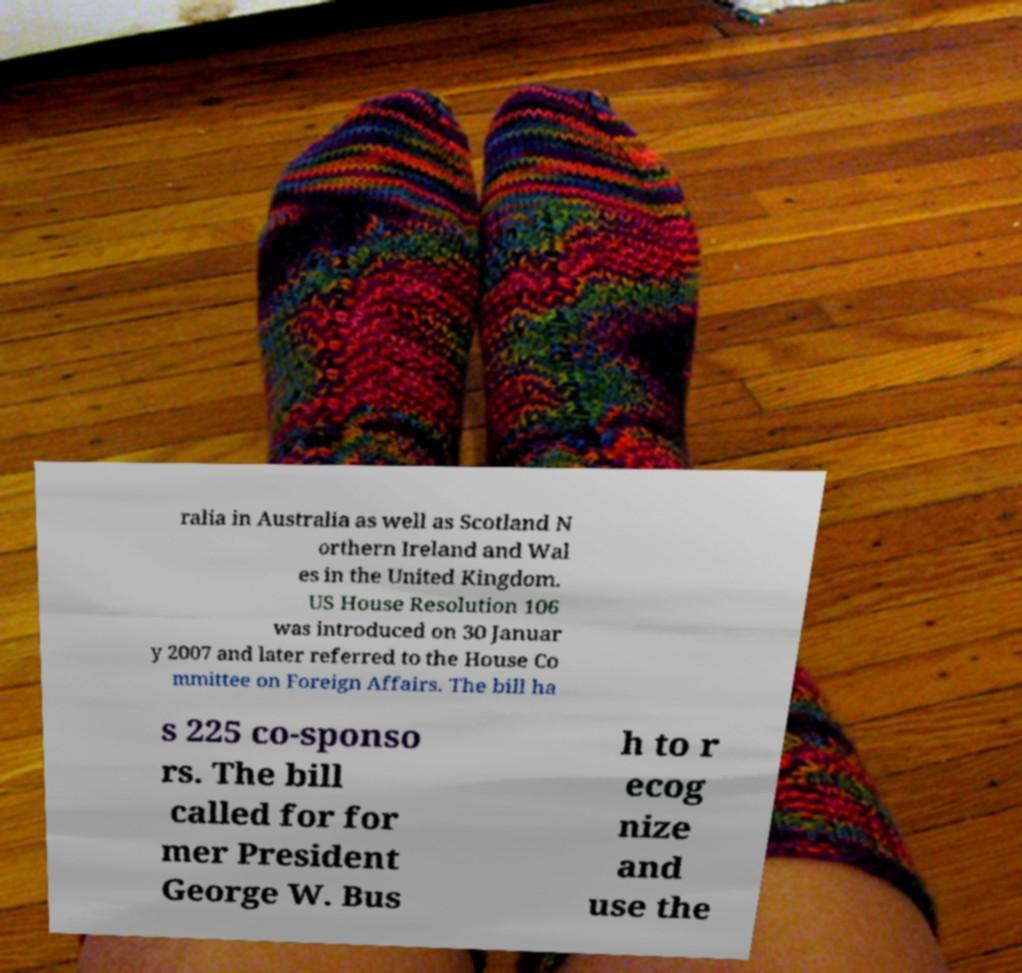Could you extract and type out the text from this image? ralia in Australia as well as Scotland N orthern Ireland and Wal es in the United Kingdom. US House Resolution 106 was introduced on 30 Januar y 2007 and later referred to the House Co mmittee on Foreign Affairs. The bill ha s 225 co-sponso rs. The bill called for for mer President George W. Bus h to r ecog nize and use the 